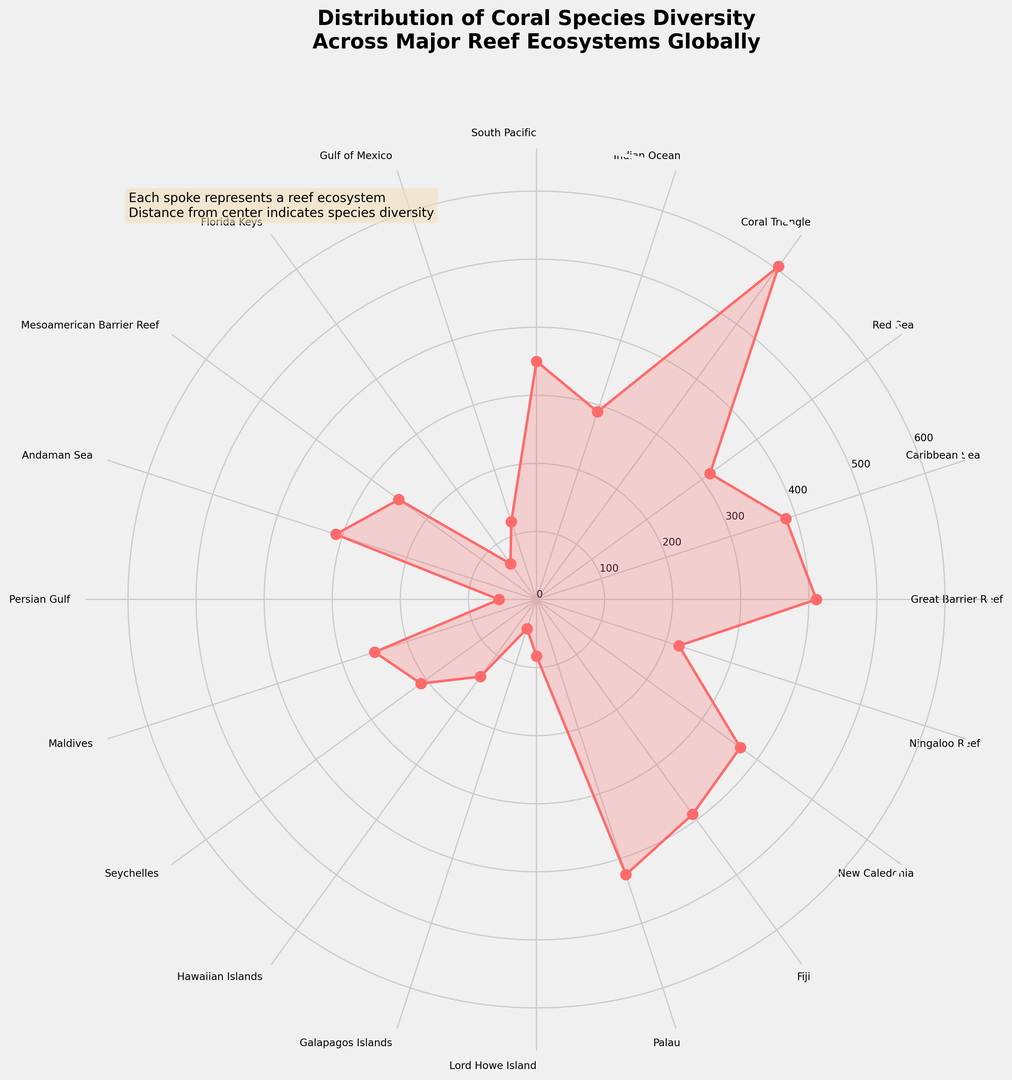Which reef ecosystem has the highest coral species diversity? Viewed from the plot, the outermost spoke identifies the reef with the highest species diversity. The Coral Triangle is the zenith point in the visual display.
Answer: Coral Triangle Which reef ecosystem has the lowest coral species diversity? The innermost spoke pinpoints the reef with minimal species diversity, which in this case is identified as the Persian Gulf.
Answer: Persian Gulf How does the coral species diversity of the Great Barrier Reef compare to the Caribbean Sea? Comparing the spoke lengths, the Great Barrier Reef's spoke is marginally longer than that of the Caribbean Sea. This indicates slightly greater species diversity at the Great Barrier Reef.
Answer: Greater at Great Barrier Reef Is the species diversity in the South Pacific greater than in the Indian Ocean? By comparing the respective spokes, the South Pacific's spoke is noticeably longer, indicating higher species diversity compared to the Indian Ocean.
Answer: Yes What is the disparity in coral species diversity between the Coral Triangle and the Florida Keys? By evaluating the plot, the Coral Triangle's species diversity is far superior. The mathematical difference between the Coral Triangle (605) and the Florida Keys (65) is calculated to be 605 - 65 = 540.
Answer: 540 What two reef ecosystems have coral species diversities close to 250? Spokes representing the Mesoamerican Barrier Reef and the Maldives both approximate a coral species diversity near 250.
Answer: Mesoamerican Barrier Reef, Maldives Calculate the average species diversity of the Gulf of Mexico, Florida Keys, and Persian Gulf. Species diversity values for these locations are summed up as 120 + 65 + 55. This total (240) is divided by 3 (number of ecosystems). The calculated average equals 240/3 = 80.
Answer: 80 Find the median species diversity among the listed reef ecosystems. The given species diversity values are organized in ascending order: 45, 55, 65, 83, 120, 140, 210, 220, 250, 250, 290, 310, 315, 350, 370, 385, 390, 411, 425, 605. Since there are 20 values, the median is the average of the 10th and 11th values. The median thus is (250 + 290) / 2 = 270.
Answer: 270 Which reef ecosystem located in the Indian Ocean has a species diversity closer to the South Pacific? In the Indian Ocean vicinity, the Indian Ocean reef ecosystem's species diversity is contrasted with that of the South Pacific. The South Pacific scores 350 in species diversity, while the Indian Ocean rates at 290. Hence, the Indian Ocean is closer.
Answer: Indian Ocean Are there any reef ecosystems with exactly the same coral species diversity? Upon inspection of the plot, the Mesoamerican Barrier Reef and the Maldives show identical species diversity figures of 250.
Answer: Yes, Mesoamerican Barrier Reef and Maldives 